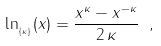<formula> <loc_0><loc_0><loc_500><loc_500>\ln _ { _ { \{ \kappa \} } } ( x ) = \frac { x ^ { \kappa } - x ^ { - \kappa } } { 2 \, \kappa } \ ,</formula> 